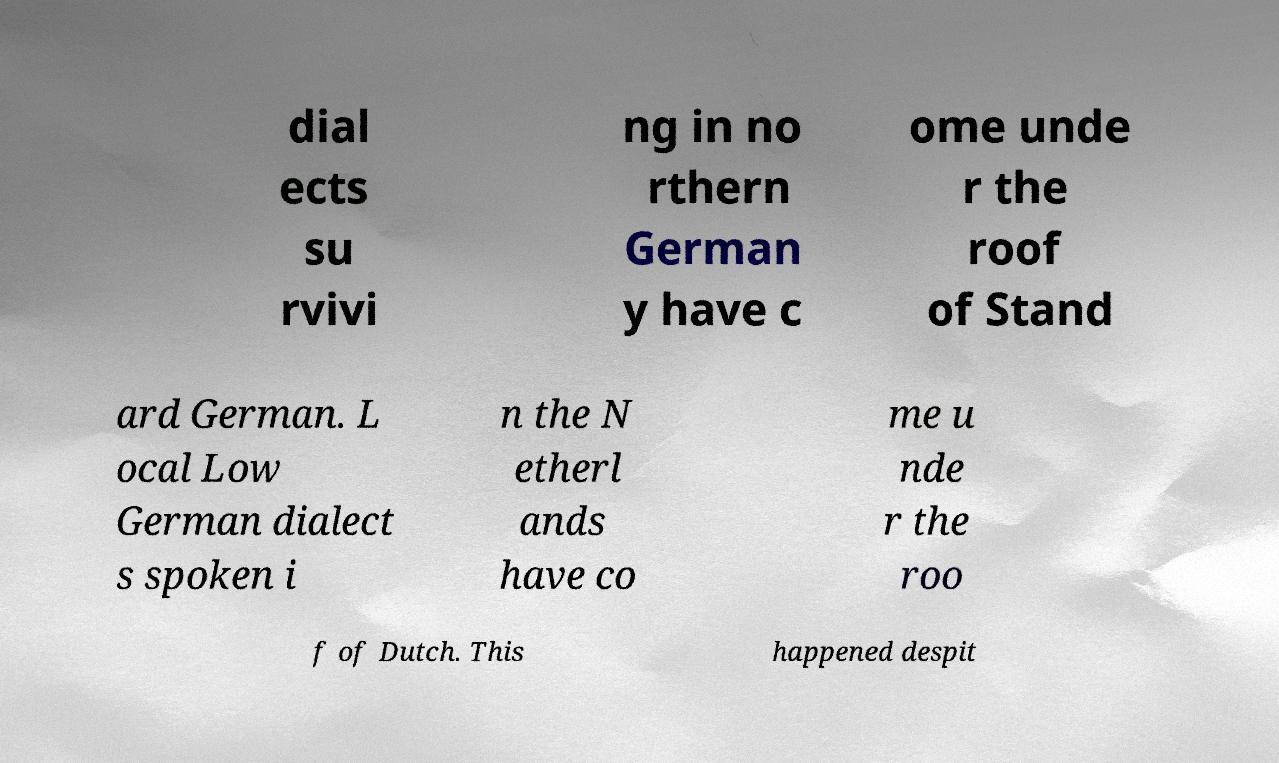Could you extract and type out the text from this image? dial ects su rvivi ng in no rthern German y have c ome unde r the roof of Stand ard German. L ocal Low German dialect s spoken i n the N etherl ands have co me u nde r the roo f of Dutch. This happened despit 